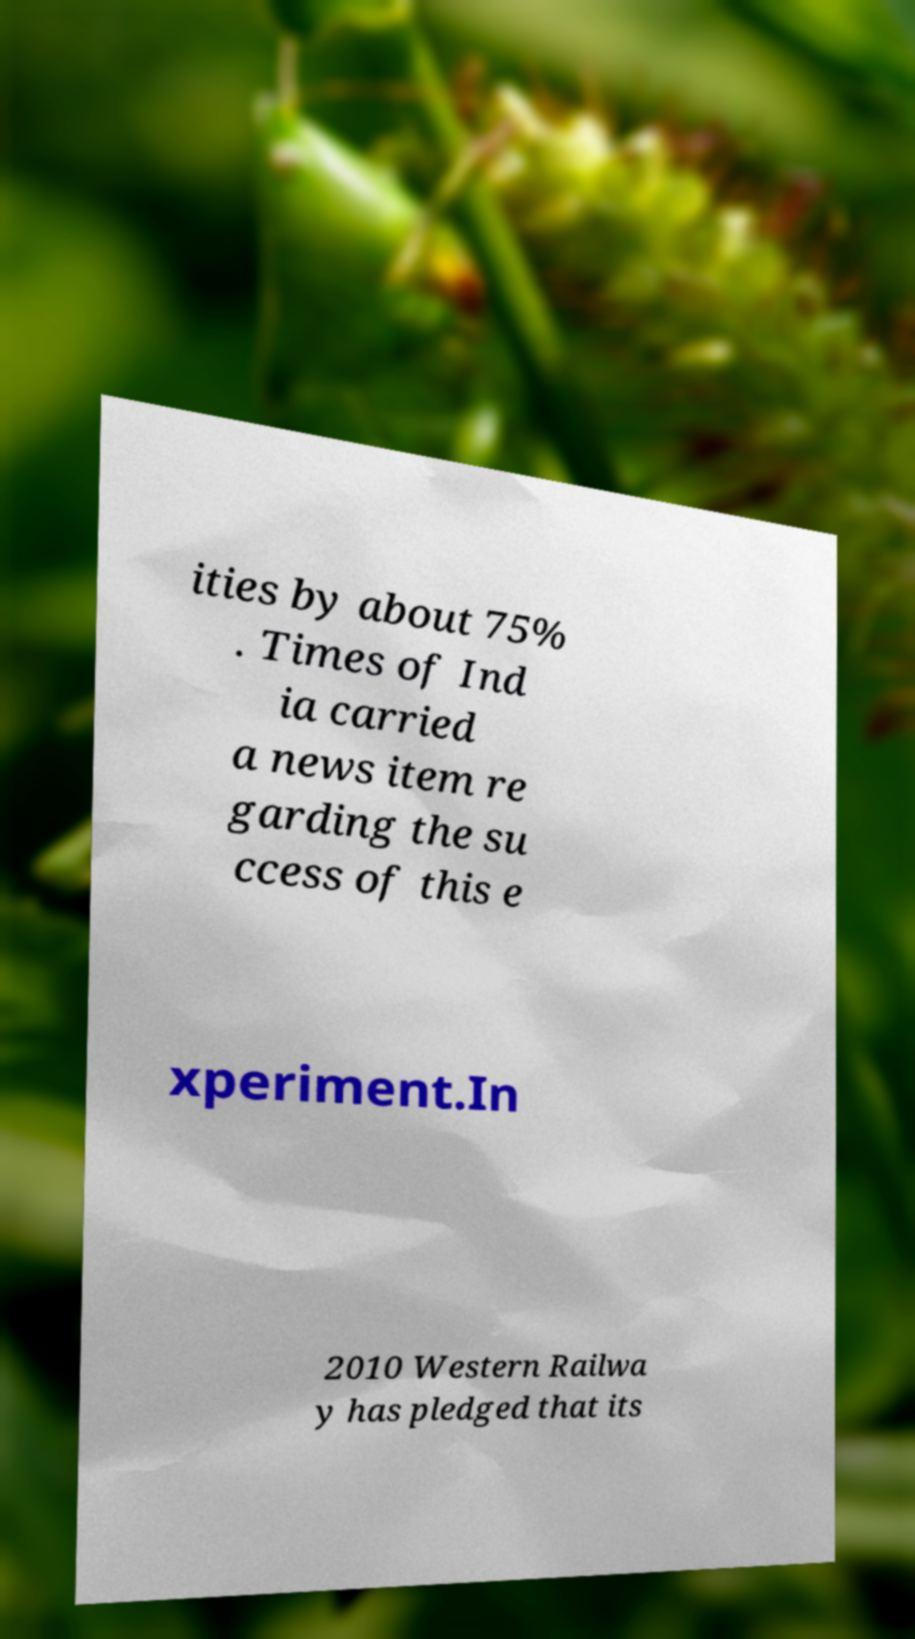There's text embedded in this image that I need extracted. Can you transcribe it verbatim? ities by about 75% . Times of Ind ia carried a news item re garding the su ccess of this e xperiment.In 2010 Western Railwa y has pledged that its 